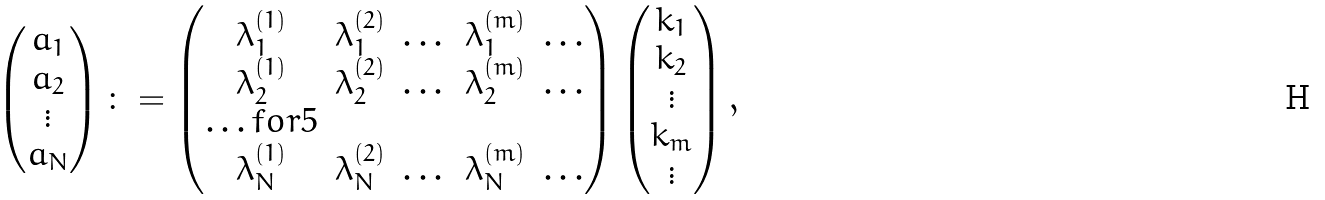Convert formula to latex. <formula><loc_0><loc_0><loc_500><loc_500>\begin{pmatrix} a _ { 1 } \\ a _ { 2 } \\ \vdots \\ a _ { N } \end{pmatrix} \colon = \begin{pmatrix} \lambda _ { 1 } ^ { ( 1 ) } & \lambda _ { 1 } ^ { ( 2 ) } & \dots & \lambda _ { 1 } ^ { ( m ) } & \dots \\ \lambda _ { 2 } ^ { ( 1 ) } & \lambda _ { 2 } ^ { ( 2 ) } & \dots & \lambda _ { 2 } ^ { ( m ) } & \dots \\ \hdots f o r { 5 } \\ \lambda _ { N } ^ { ( 1 ) } & \lambda _ { N } ^ { ( 2 ) } & \dots & \lambda _ { N } ^ { ( m ) } & \dots \end{pmatrix} \begin{pmatrix} k _ { 1 } \\ k _ { 2 } \\ \vdots \\ k _ { m } \\ \vdots \end{pmatrix} ,</formula> 